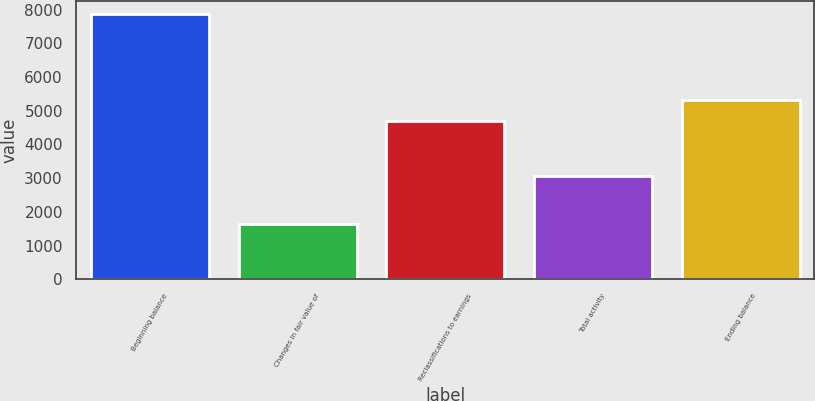Convert chart. <chart><loc_0><loc_0><loc_500><loc_500><bar_chart><fcel>Beginning balance<fcel>Changes in fair value of<fcel>Reclassifications to earnings<fcel>Total activity<fcel>Ending balance<nl><fcel>7874<fcel>1627<fcel>4702<fcel>3075<fcel>5326.7<nl></chart> 